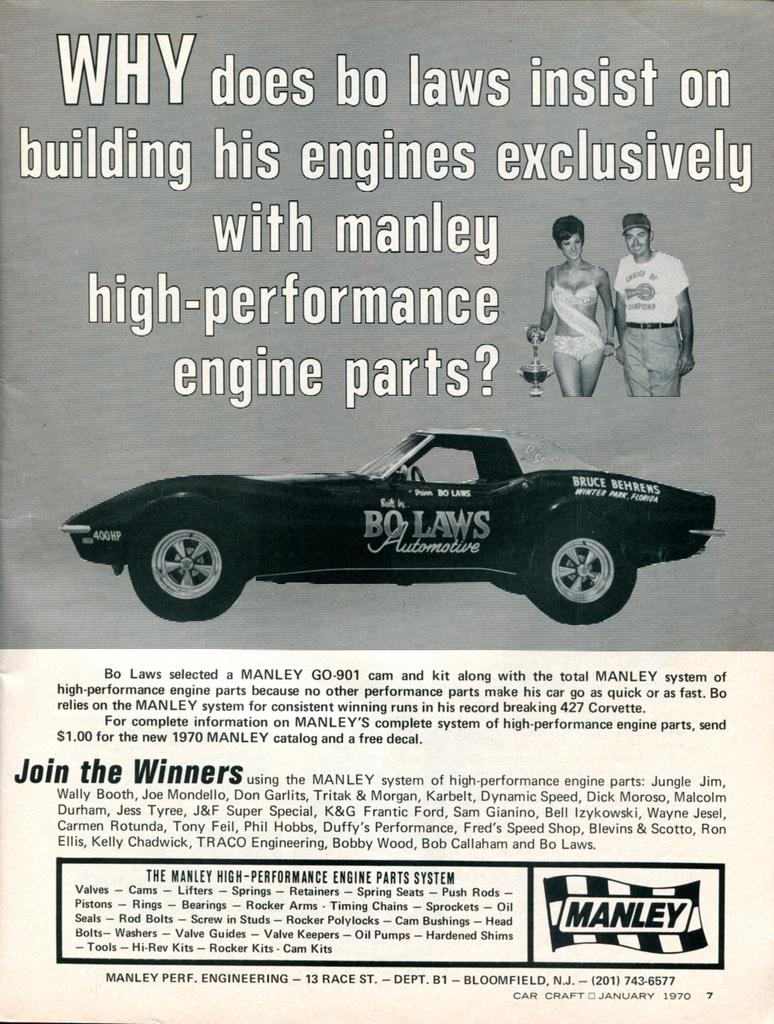What is the main object in the image? There is a paper in the image. What is depicted on the paper? There is a car in the center of the paper. Is there any text on the paper? Yes, there is text written at the bottom and top of the paper. Who or what is present on the right side of the image? There are two people standing on the right side of the image. Can you see any veins in the car on the paper? There are no veins present in the car on the paper, as veins are a biological feature found in living organisms and not in vehicles. 